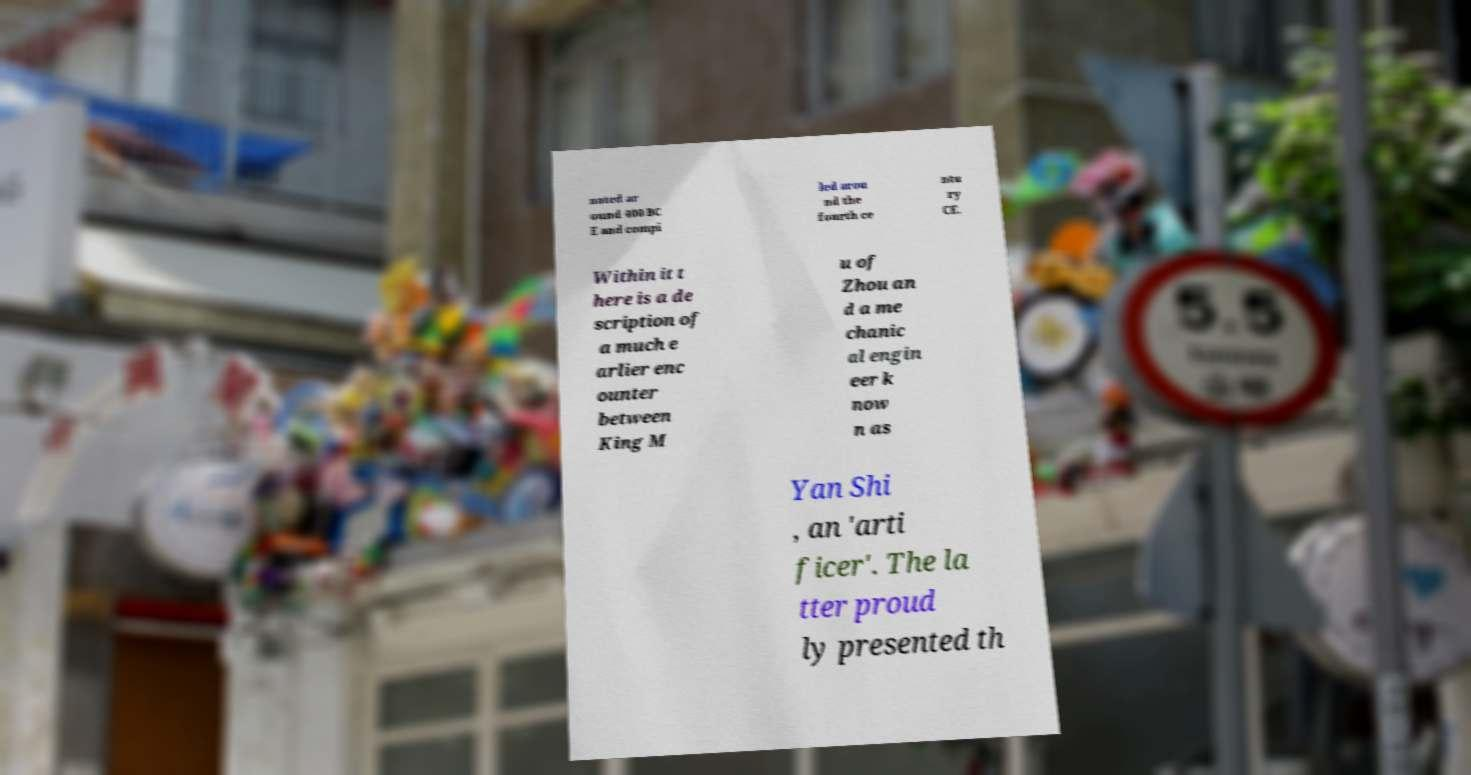Please identify and transcribe the text found in this image. nated ar ound 400 BC E and compi led arou nd the fourth ce ntu ry CE. Within it t here is a de scription of a much e arlier enc ounter between King M u of Zhou an d a me chanic al engin eer k now n as Yan Shi , an 'arti ficer'. The la tter proud ly presented th 